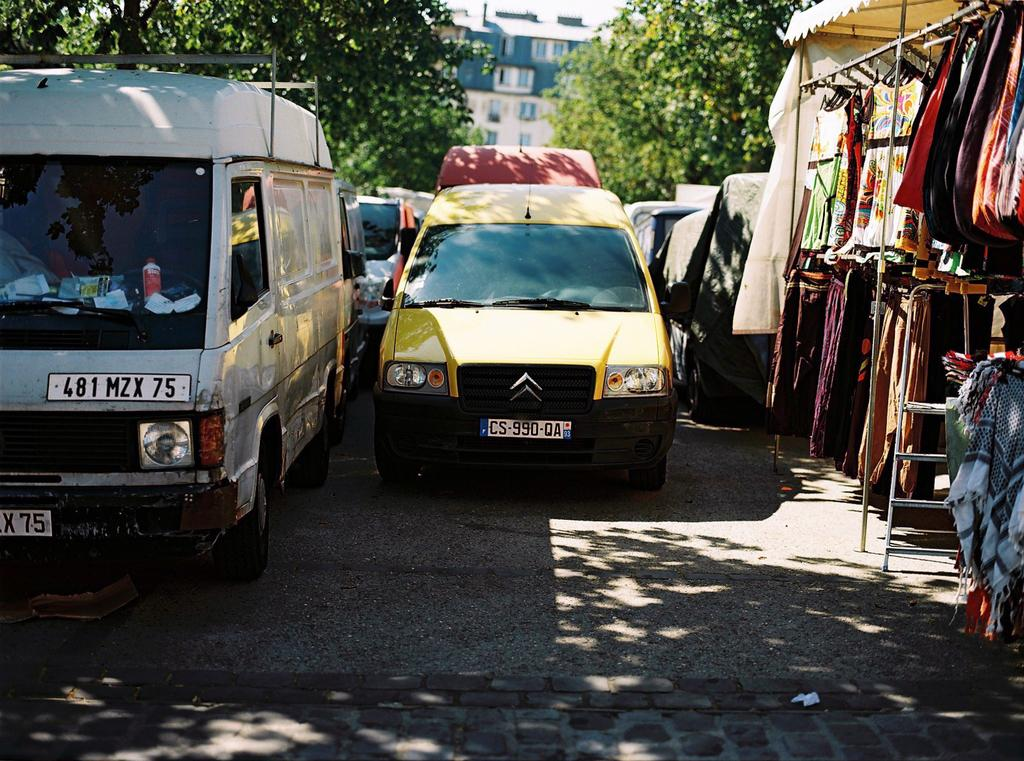What can be seen parked on the road in the image? There are vehicles parked on the road in the image. What is hanging in the image? There are clothes on a hanger in the image. What type of natural vegetation is visible in the image? There are trees visible in the image. What type of structure can be seen in the image? There is a building in the image. What type of vest is being worn by the brother in the image? There is no brother or vest present in the image. What type of sheet is covering the bed in the image? There is no bed or sheet present in the image. 